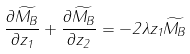<formula> <loc_0><loc_0><loc_500><loc_500>\frac { \partial \widetilde { M _ { B } } } { \partial z _ { 1 } } + \frac { \partial \widetilde { M _ { B } } } { \partial z _ { 2 } } = - 2 \lambda z _ { 1 } \widetilde { M _ { B } }</formula> 